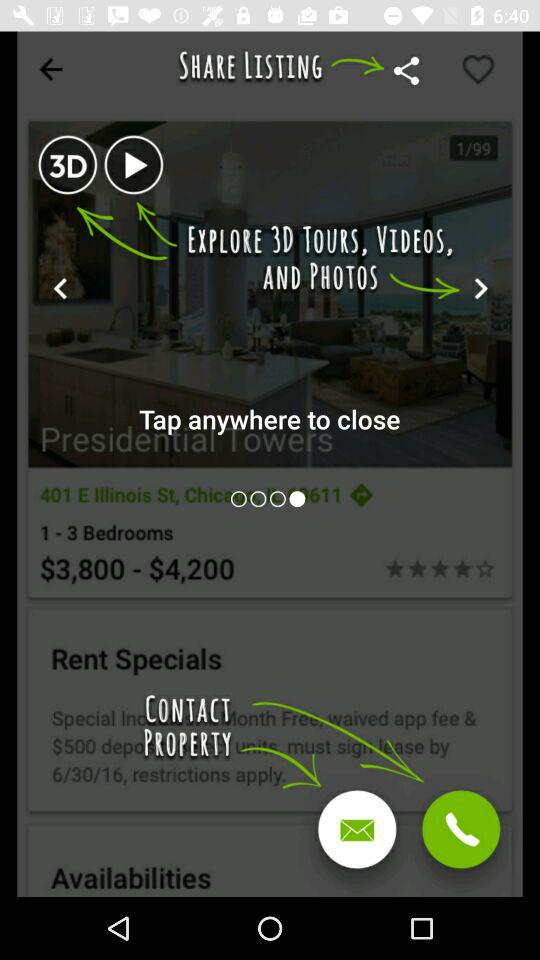What is the rent of the property having 1 to 3 bedrooms? The rent ranges from $3,800 to $4,200. 